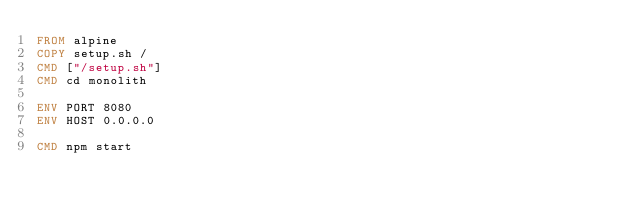<code> <loc_0><loc_0><loc_500><loc_500><_Dockerfile_>FROM alpine
COPY setup.sh /
CMD ["/setup.sh"]
CMD cd monolith

ENV PORT 8080
ENV HOST 0.0.0.0

CMD npm start
</code> 